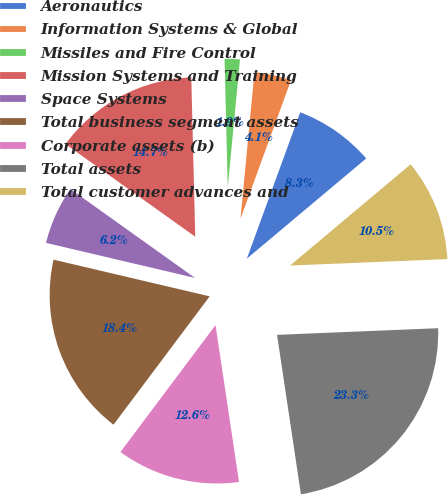Convert chart to OTSL. <chart><loc_0><loc_0><loc_500><loc_500><pie_chart><fcel>Aeronautics<fcel>Information Systems & Global<fcel>Missiles and Fire Control<fcel>Mission Systems and Training<fcel>Space Systems<fcel>Total business segment assets<fcel>Corporate assets (b)<fcel>Total assets<fcel>Total customer advances and<nl><fcel>8.32%<fcel>4.05%<fcel>1.91%<fcel>14.74%<fcel>6.19%<fcel>18.44%<fcel>12.6%<fcel>23.29%<fcel>10.46%<nl></chart> 